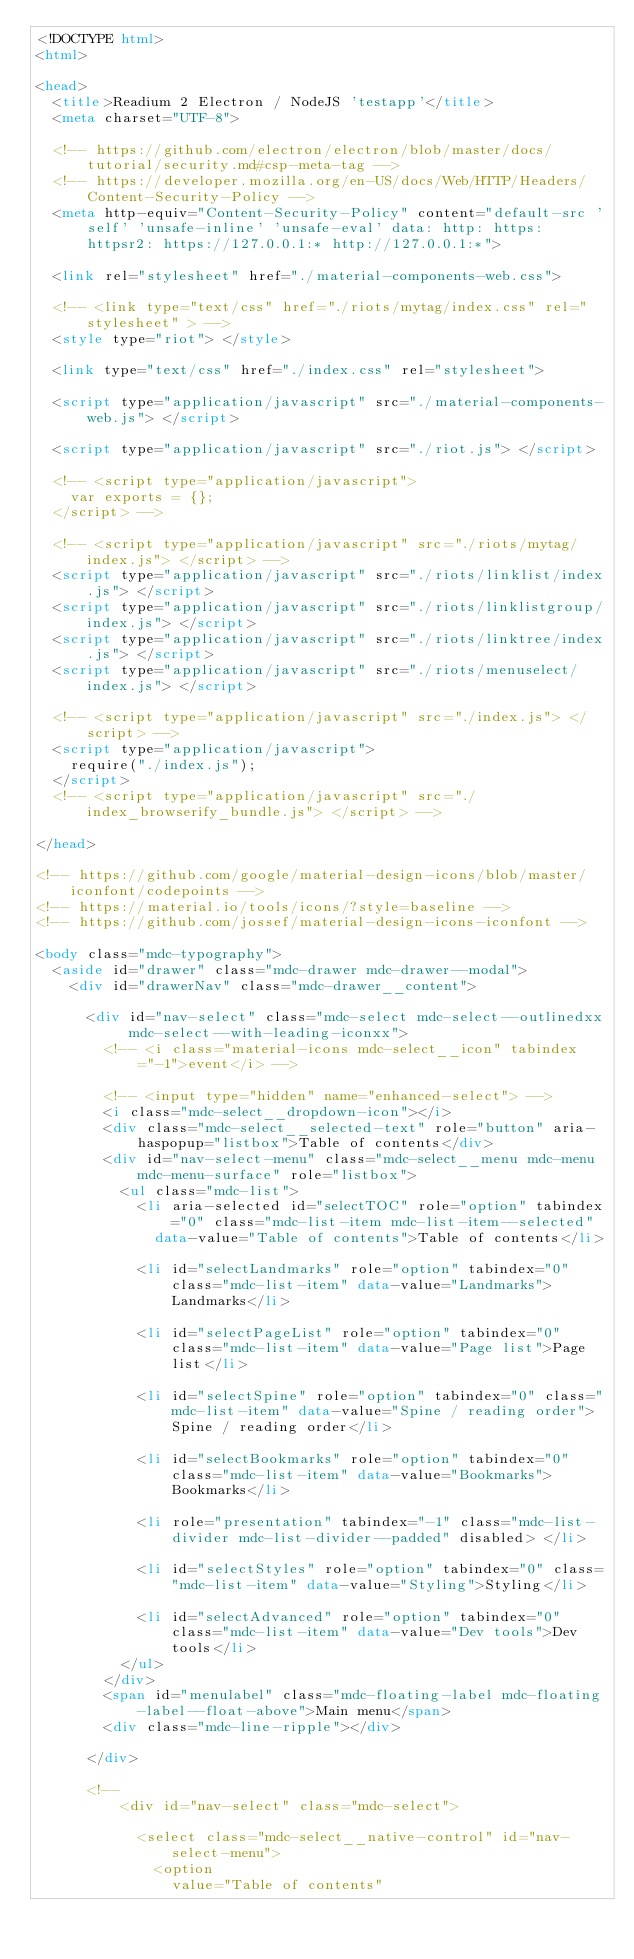Convert code to text. <code><loc_0><loc_0><loc_500><loc_500><_HTML_><!DOCTYPE html>
<html>

<head>
  <title>Readium 2 Electron / NodeJS 'testapp'</title>
  <meta charset="UTF-8">

  <!-- https://github.com/electron/electron/blob/master/docs/tutorial/security.md#csp-meta-tag -->
  <!-- https://developer.mozilla.org/en-US/docs/Web/HTTP/Headers/Content-Security-Policy -->
  <meta http-equiv="Content-Security-Policy" content="default-src 'self' 'unsafe-inline' 'unsafe-eval' data: http: https: httpsr2: https://127.0.0.1:* http://127.0.0.1:*">

  <link rel="stylesheet" href="./material-components-web.css">

  <!-- <link type="text/css" href="./riots/mytag/index.css" rel="stylesheet" > -->
  <style type="riot"> </style>

  <link type="text/css" href="./index.css" rel="stylesheet">

  <script type="application/javascript" src="./material-components-web.js"> </script>

  <script type="application/javascript" src="./riot.js"> </script>

  <!-- <script type="application/javascript">
    var exports = {};
  </script> -->

  <!-- <script type="application/javascript" src="./riots/mytag/index.js"> </script> -->
  <script type="application/javascript" src="./riots/linklist/index.js"> </script>
  <script type="application/javascript" src="./riots/linklistgroup/index.js"> </script>
  <script type="application/javascript" src="./riots/linktree/index.js"> </script>
  <script type="application/javascript" src="./riots/menuselect/index.js"> </script>

  <!-- <script type="application/javascript" src="./index.js"> </script> -->
  <script type="application/javascript">
    require("./index.js");
  </script>
  <!-- <script type="application/javascript" src="./index_browserify_bundle.js"> </script> -->

</head>

<!-- https://github.com/google/material-design-icons/blob/master/iconfont/codepoints -->
<!-- https://material.io/tools/icons/?style=baseline -->
<!-- https://github.com/jossef/material-design-icons-iconfont -->

<body class="mdc-typography">
  <aside id="drawer" class="mdc-drawer mdc-drawer--modal">
    <div id="drawerNav" class="mdc-drawer__content">

      <div id="nav-select" class="mdc-select mdc-select--outlinedxx mdc-select--with-leading-iconxx">
        <!-- <i class="material-icons mdc-select__icon" tabindex="-1">event</i> -->

        <!-- <input type="hidden" name="enhanced-select"> -->
        <i class="mdc-select__dropdown-icon"></i>
        <div class="mdc-select__selected-text" role="button" aria-haspopup="listbox">Table of contents</div>
        <div id="nav-select-menu" class="mdc-select__menu mdc-menu mdc-menu-surface" role="listbox">
          <ul class="mdc-list">
            <li aria-selected id="selectTOC" role="option" tabindex="0" class="mdc-list-item mdc-list-item--selected"
              data-value="Table of contents">Table of contents</li>

            <li id="selectLandmarks" role="option" tabindex="0" class="mdc-list-item" data-value="Landmarks">Landmarks</li>

            <li id="selectPageList" role="option" tabindex="0" class="mdc-list-item" data-value="Page list">Page list</li>

            <li id="selectSpine" role="option" tabindex="0" class="mdc-list-item" data-value="Spine / reading order">Spine / reading order</li>

            <li id="selectBookmarks" role="option" tabindex="0" class="mdc-list-item" data-value="Bookmarks">Bookmarks</li>

            <li role="presentation" tabindex="-1" class="mdc-list-divider mdc-list-divider--padded" disabled> </li>

            <li id="selectStyles" role="option" tabindex="0" class="mdc-list-item" data-value="Styling">Styling</li>

            <li id="selectAdvanced" role="option" tabindex="0" class="mdc-list-item" data-value="Dev tools">Dev tools</li>
          </ul>
        </div>
        <span id="menulabel" class="mdc-floating-label mdc-floating-label--float-above">Main menu</span>
        <div class="mdc-line-ripple"></div>

      </div>

      <!--
          <div id="nav-select" class="mdc-select">

            <select class="mdc-select__native-control" id="nav-select-menu">
              <option
                value="Table of contents"</code> 